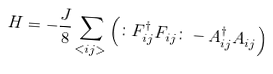<formula> <loc_0><loc_0><loc_500><loc_500>H = - \frac { J } { 8 } \sum _ { < i j > } \left ( \colon F ^ { \dagger } _ { i j } F _ { i j } \colon - A ^ { \dagger } _ { i j } A _ { i j } \right )</formula> 